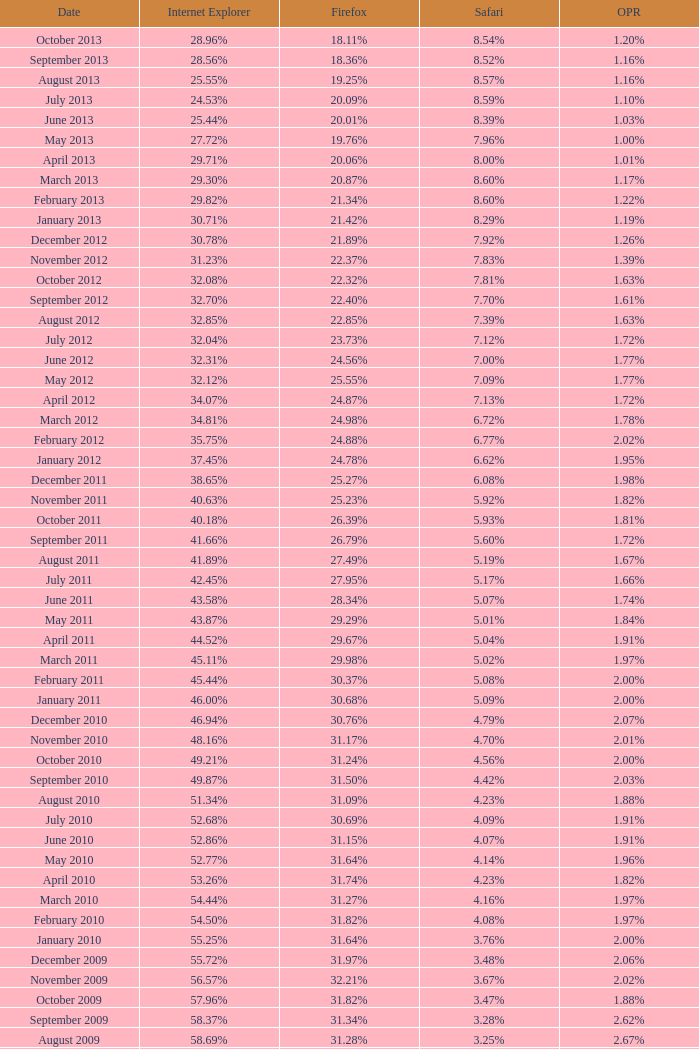What percentage of browsers were using Internet Explorer during the period in which 27.85% were using Firefox? 64.43%. 